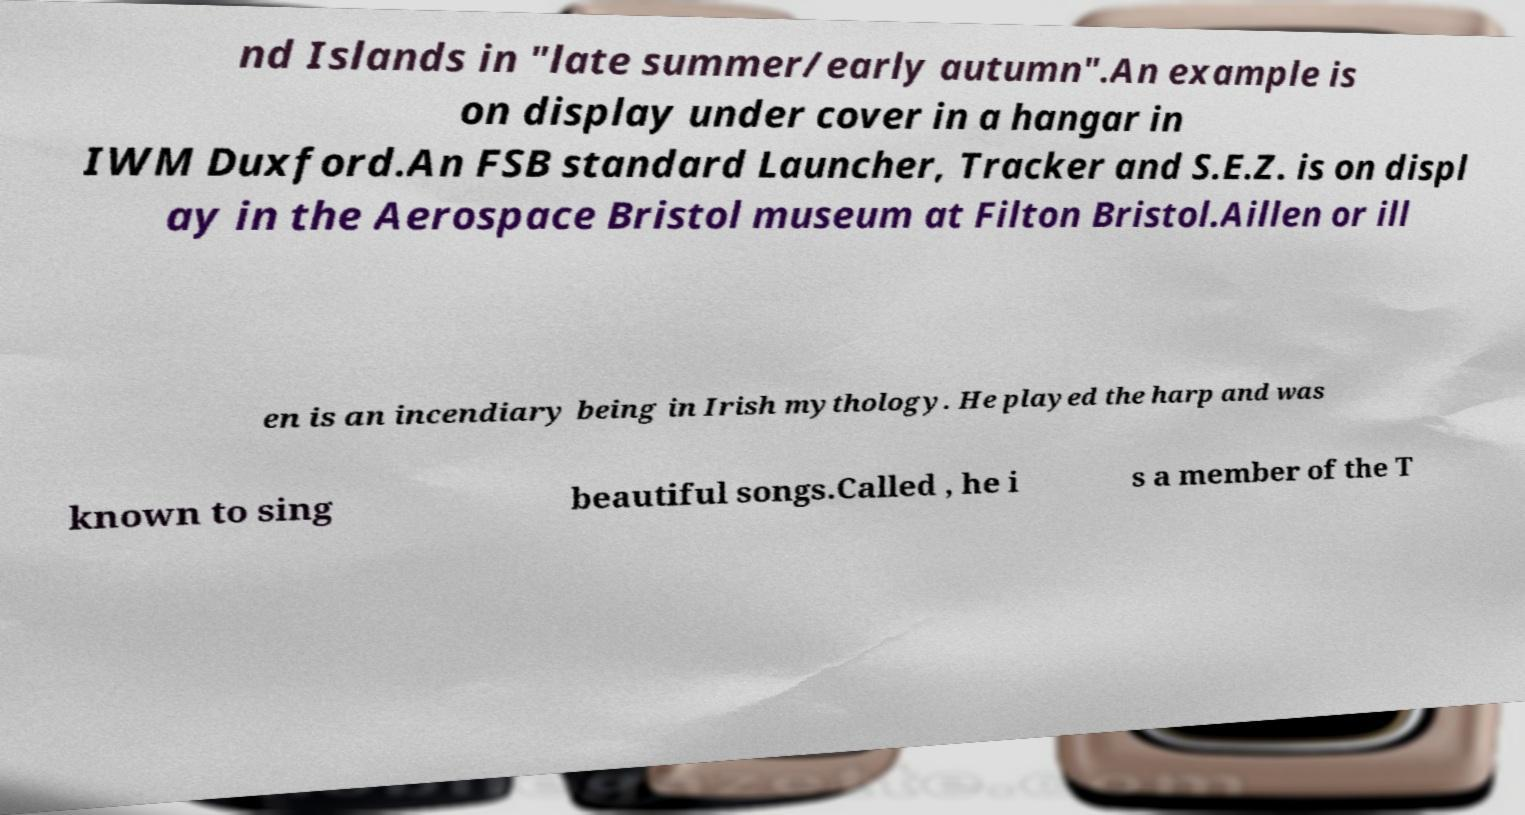Please read and relay the text visible in this image. What does it say? nd Islands in "late summer/early autumn".An example is on display under cover in a hangar in IWM Duxford.An FSB standard Launcher, Tracker and S.E.Z. is on displ ay in the Aerospace Bristol museum at Filton Bristol.Aillen or ill en is an incendiary being in Irish mythology. He played the harp and was known to sing beautiful songs.Called , he i s a member of the T 